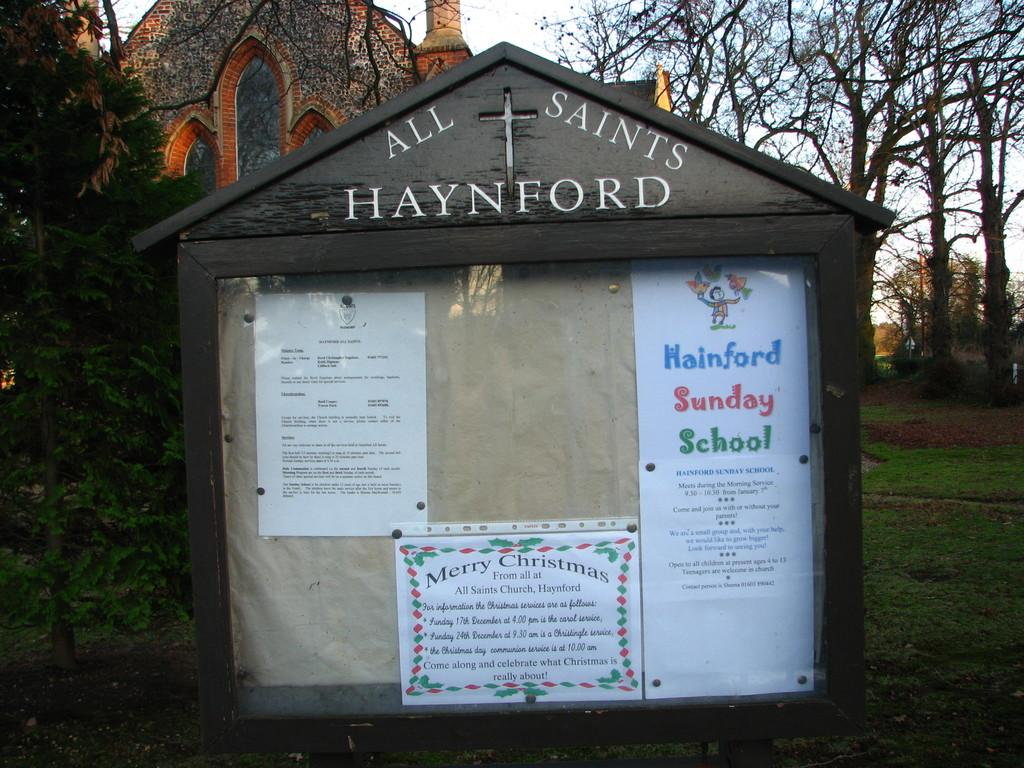What type of structure can be seen in the image? There is a building in the image. What type of vegetation is present in the image? There are trees and grass in the image. What part of the natural environment is visible in the image? The sky is visible in the image. What else can be seen in the image besides the building, trees, and grass? There are other objects in the image, including a board with papers attached to it. What type of food is being served to the zebra in the image? There is no zebra present in the image, and therefore no food being served to it. How many hens can be seen in the image? There are no hens present in the image. 